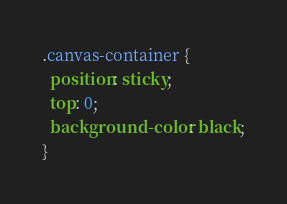Convert code to text. <code><loc_0><loc_0><loc_500><loc_500><_CSS_>.canvas-container {
  position: sticky;
  top: 0;
  background-color: black;
}
</code> 